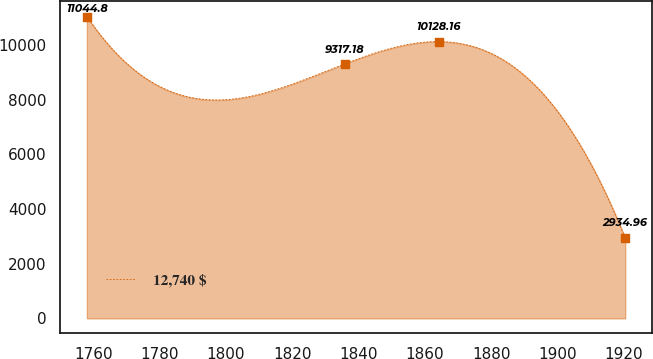Convert chart to OTSL. <chart><loc_0><loc_0><loc_500><loc_500><line_chart><ecel><fcel>12,740 $<nl><fcel>1758.03<fcel>11044.8<nl><fcel>1835.9<fcel>9317.18<nl><fcel>1864.29<fcel>10128.2<nl><fcel>1920.41<fcel>2934.96<nl></chart> 